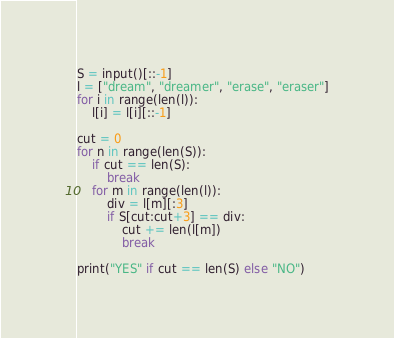<code> <loc_0><loc_0><loc_500><loc_500><_Python_>S = input()[::-1]
l = ["dream", "dreamer", "erase", "eraser"]
for i in range(len(l)):
    l[i] = l[i][::-1]

cut = 0
for n in range(len(S)):
    if cut == len(S):
        break
    for m in range(len(l)):
        div = l[m][:3]
        if S[cut:cut+3] == div:
            cut += len(l[m])
            break

print("YES" if cut == len(S) else "NO")
</code> 